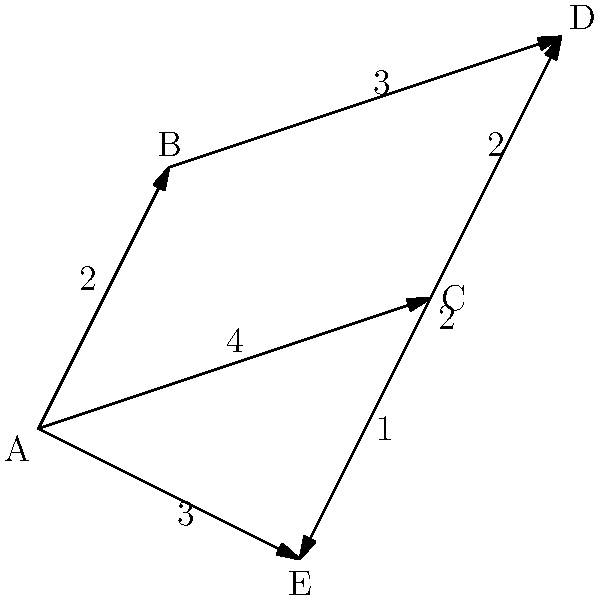A nature photographer wants to visit five scenic viewpoints (A, B, C, D, and E) in a national park. The graph shows the hiking trails between viewpoints, with the numbers representing the time in hours to travel between them. Starting from viewpoint A, what is the minimum time required to visit all viewpoints and return to A? To find the minimum time required to visit all viewpoints and return to A, we need to solve the Traveling Salesman Problem (TSP). For this small graph, we can use a step-by-step approach:

1. List all possible routes starting and ending at A:
   A-B-C-D-E-A, A-B-D-C-E-A, A-C-B-D-E-A, A-C-D-B-E-A, A-E-B-C-D-A, A-E-C-B-D-A

2. Calculate the total time for each route:
   A-B-C-D-E-A: 2 + 4 + 2 + 2 + 3 = 13 hours
   A-B-D-C-E-A: 2 + 3 + 2 + 1 + 3 = 11 hours
   A-C-B-D-E-A: 4 + 5 + 3 + 2 + 3 = 17 hours
   A-C-D-B-E-A: 4 + 2 + 3 + 5 + 3 = 17 hours
   A-E-B-C-D-A: 3 + 5 + 4 + 2 + 4 = 18 hours
   A-E-C-B-D-A: 3 + 1 + 5 + 3 + 4 = 16 hours

3. Identify the route with the minimum total time:
   A-B-D-C-E-A with 11 hours

Therefore, the minimum time required to visit all viewpoints and return to A is 11 hours.
Answer: 11 hours 